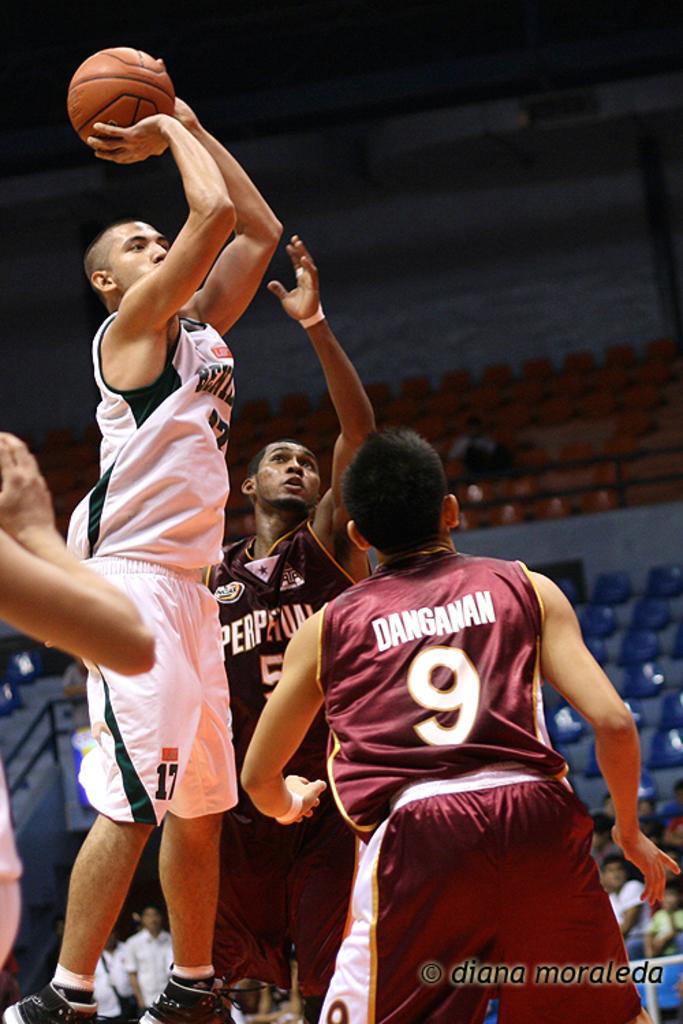What color is number 9's jersey?
Your answer should be very brief. Answering does not require reading text in the image. What number is on the players white shorts?
Keep it short and to the point. 17. 